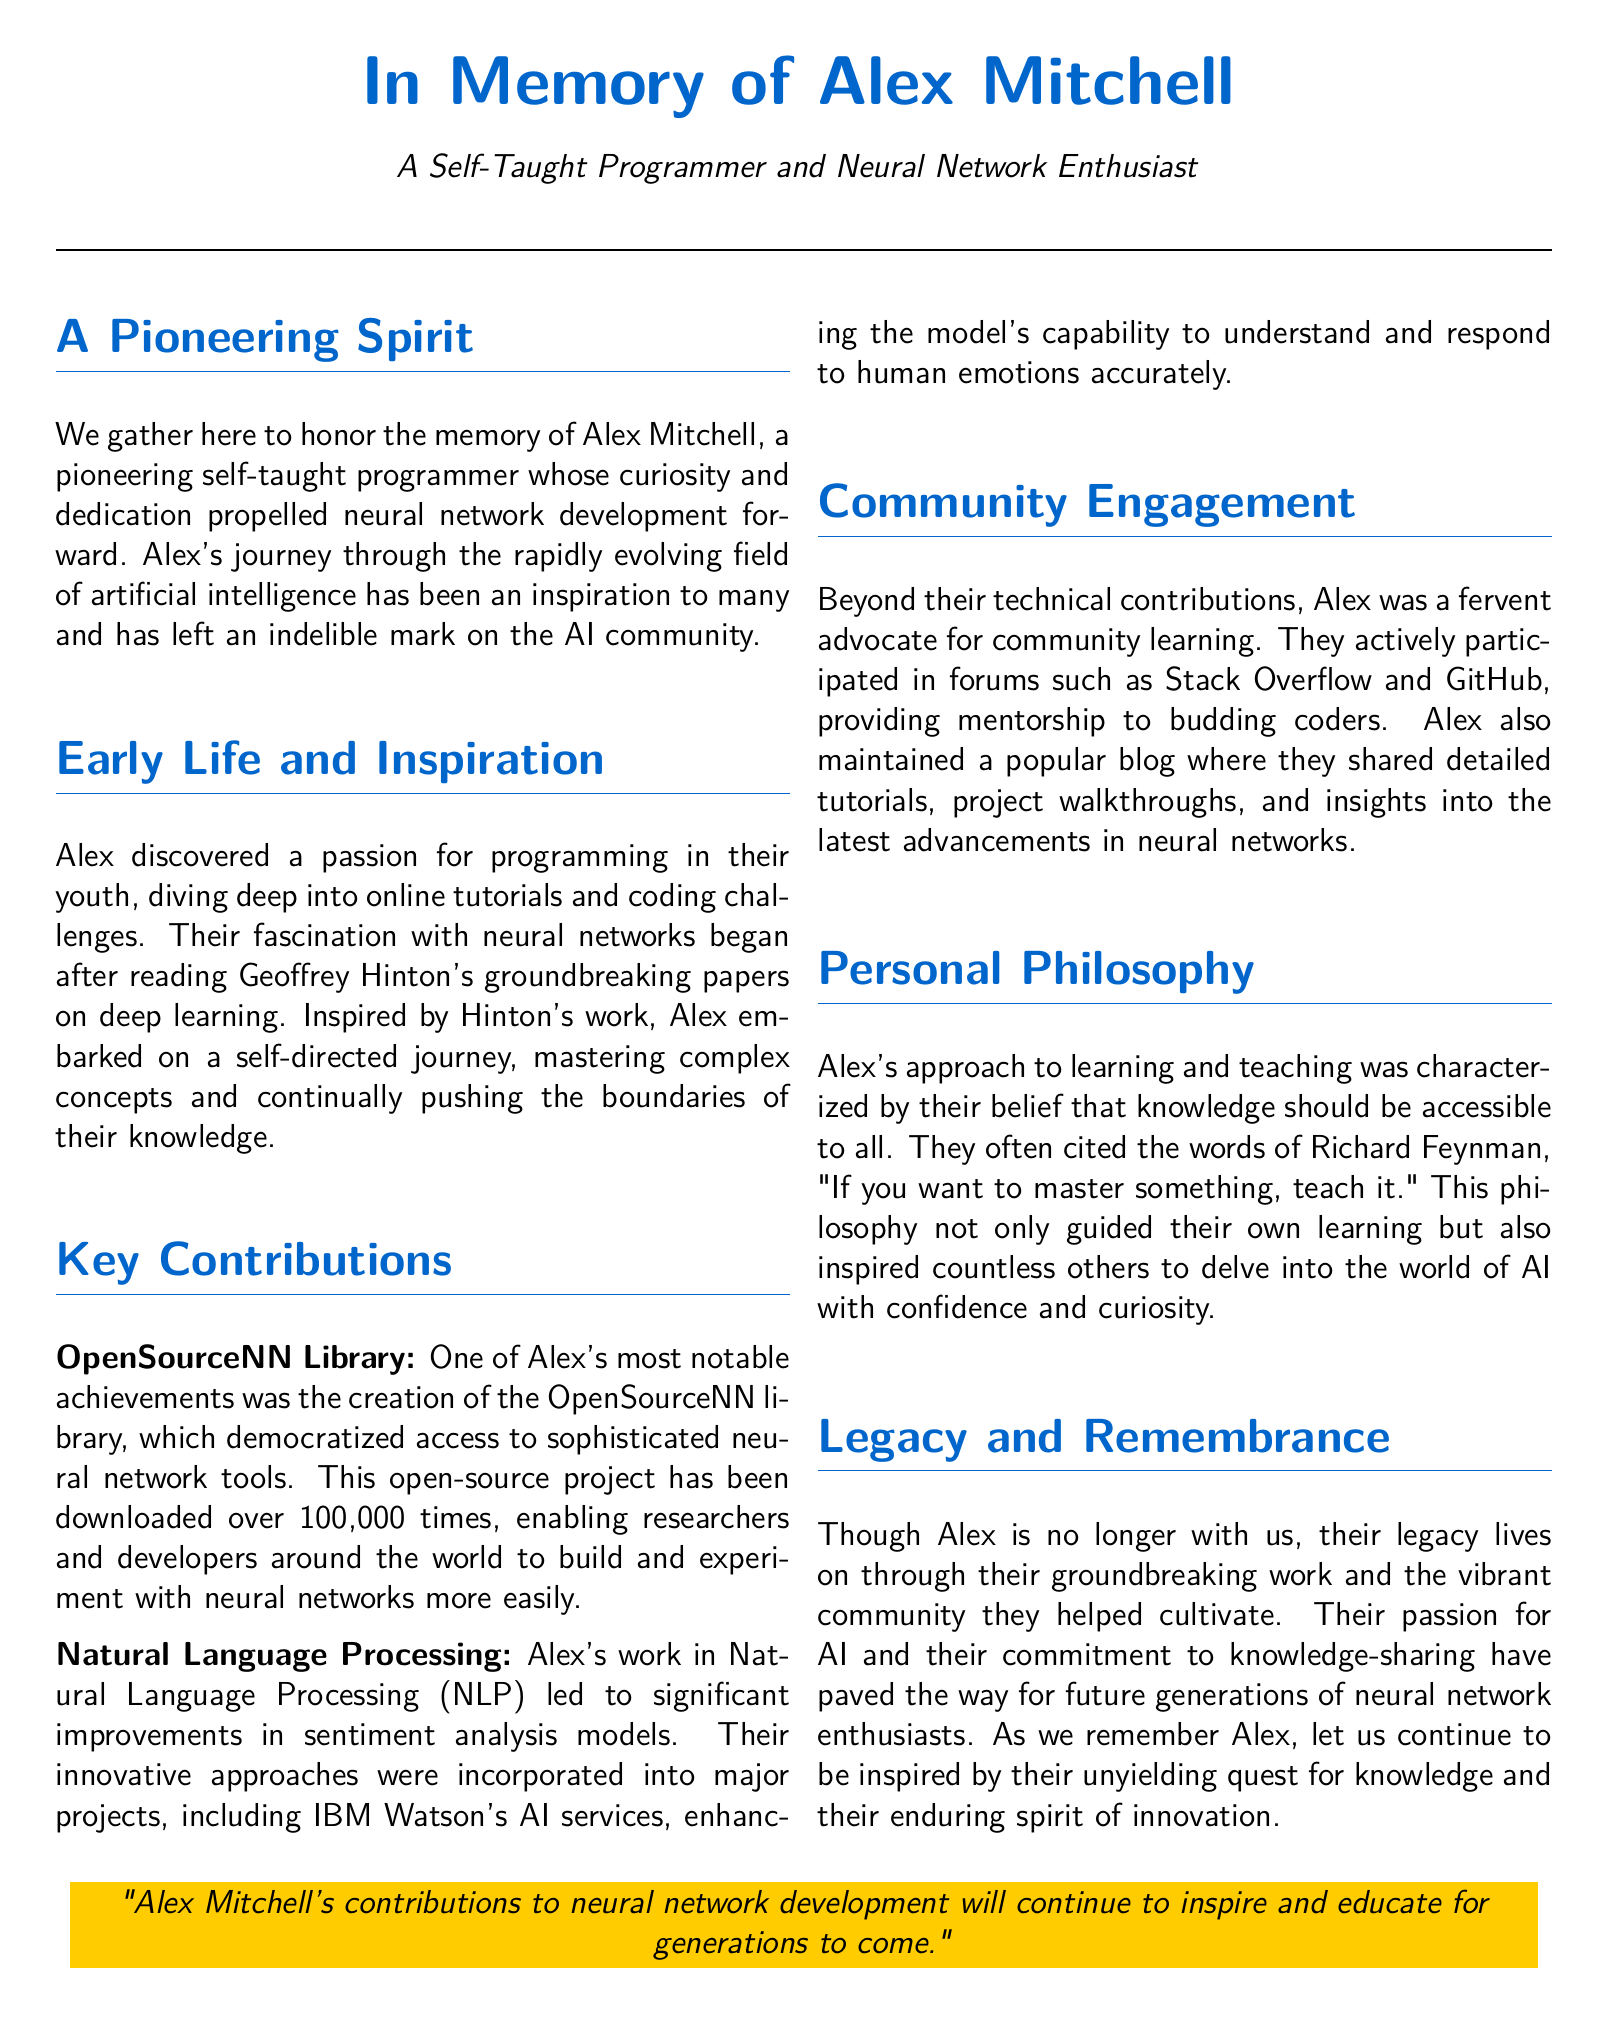What was Alex Mitchell's profession? Alex Mitchell was a self-taught programmer.
Answer: self-taught programmer What notable library did Alex create? The document identifies one of Alex's achievements as the creation of the OpenSourceNN library.
Answer: OpenSourceNN library How many times was the OpenSourceNN library downloaded? The document states that the library has been downloaded over 100,000 times.
Answer: over 100,000 times Which major project incorporated Alex's NLP work? The document cites that Alex's work was incorporated into IBM Watson's AI services.
Answer: IBM Watson What philosophy guided Alex's approach to learning and teaching? Alex believed that knowledge should be accessible to all and often cited Richard Feynman's quote about mastering something by teaching it.
Answer: knowledge should be accessible to all What was the primary focus of Alex’s contributions in AI? The document indicates that Alex's contributions focused on neural networks and natural language processing (NLP).
Answer: neural networks and natural language processing In what online communities did Alex actively participate? The document mentions that Alex participated in forums like Stack Overflow and GitHub.
Answer: Stack Overflow and GitHub What was the emotional impact of Alex's contributions on the community? Alex's contributions inspired many and left an indelible mark on the AI community.
Answer: inspired many What was Alex's early source of inspiration for programming? Alex's inspiration for programming came from online tutorials and coding challenges.
Answer: online tutorials and coding challenges 